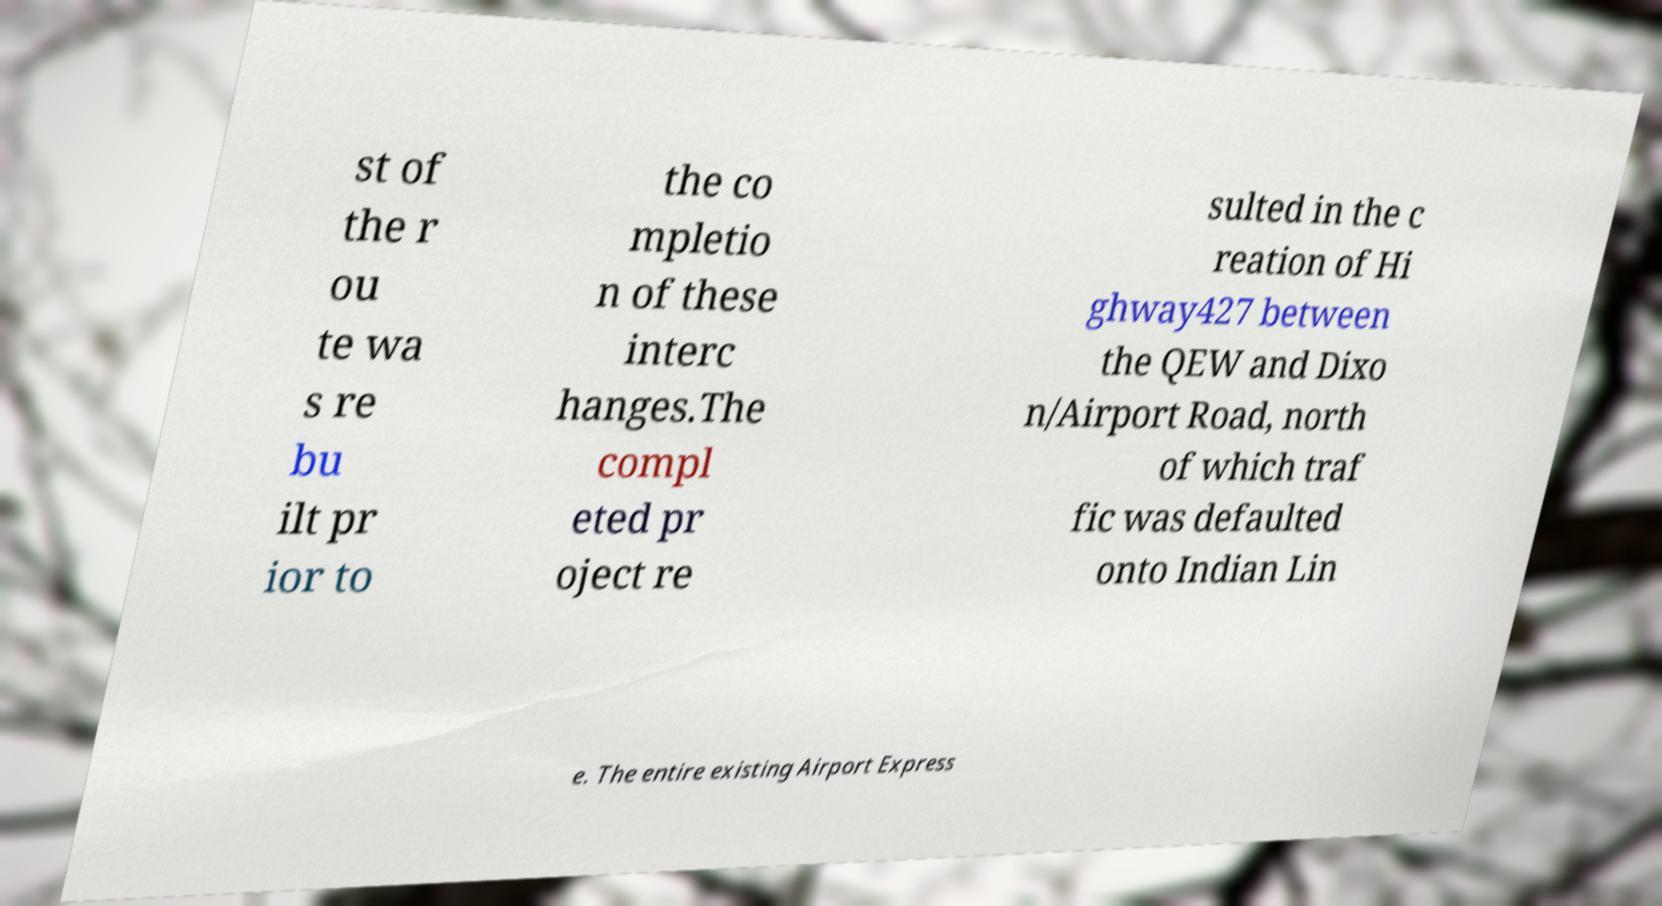Can you read and provide the text displayed in the image?This photo seems to have some interesting text. Can you extract and type it out for me? st of the r ou te wa s re bu ilt pr ior to the co mpletio n of these interc hanges.The compl eted pr oject re sulted in the c reation of Hi ghway427 between the QEW and Dixo n/Airport Road, north of which traf fic was defaulted onto Indian Lin e. The entire existing Airport Express 